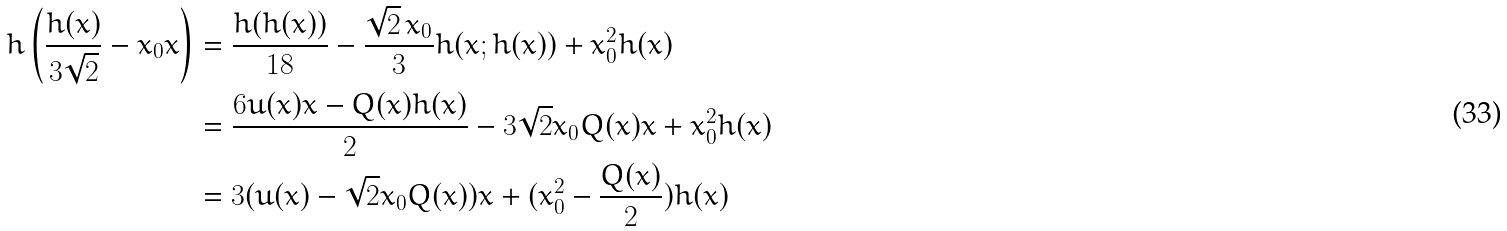Convert formula to latex. <formula><loc_0><loc_0><loc_500><loc_500>h \left ( \frac { h ( x ) } { 3 \sqrt { 2 } } - x _ { 0 } x \right ) & = \frac { h ( h ( x ) ) } { 1 8 } - \frac { \sqrt { 2 } \, x _ { 0 } } { 3 } h ( x ; h ( x ) ) + x _ { 0 } ^ { 2 } h ( x ) \\ & = \frac { 6 u ( x ) x - Q ( x ) h ( x ) } { 2 } - 3 \sqrt { 2 } x _ { 0 } Q ( x ) x + x _ { 0 } ^ { 2 } h ( x ) \\ & = 3 ( u ( x ) - \sqrt { 2 } x _ { 0 } Q ( x ) ) x + ( x _ { 0 } ^ { 2 } - \frac { Q ( x ) } { 2 } ) h ( x )</formula> 